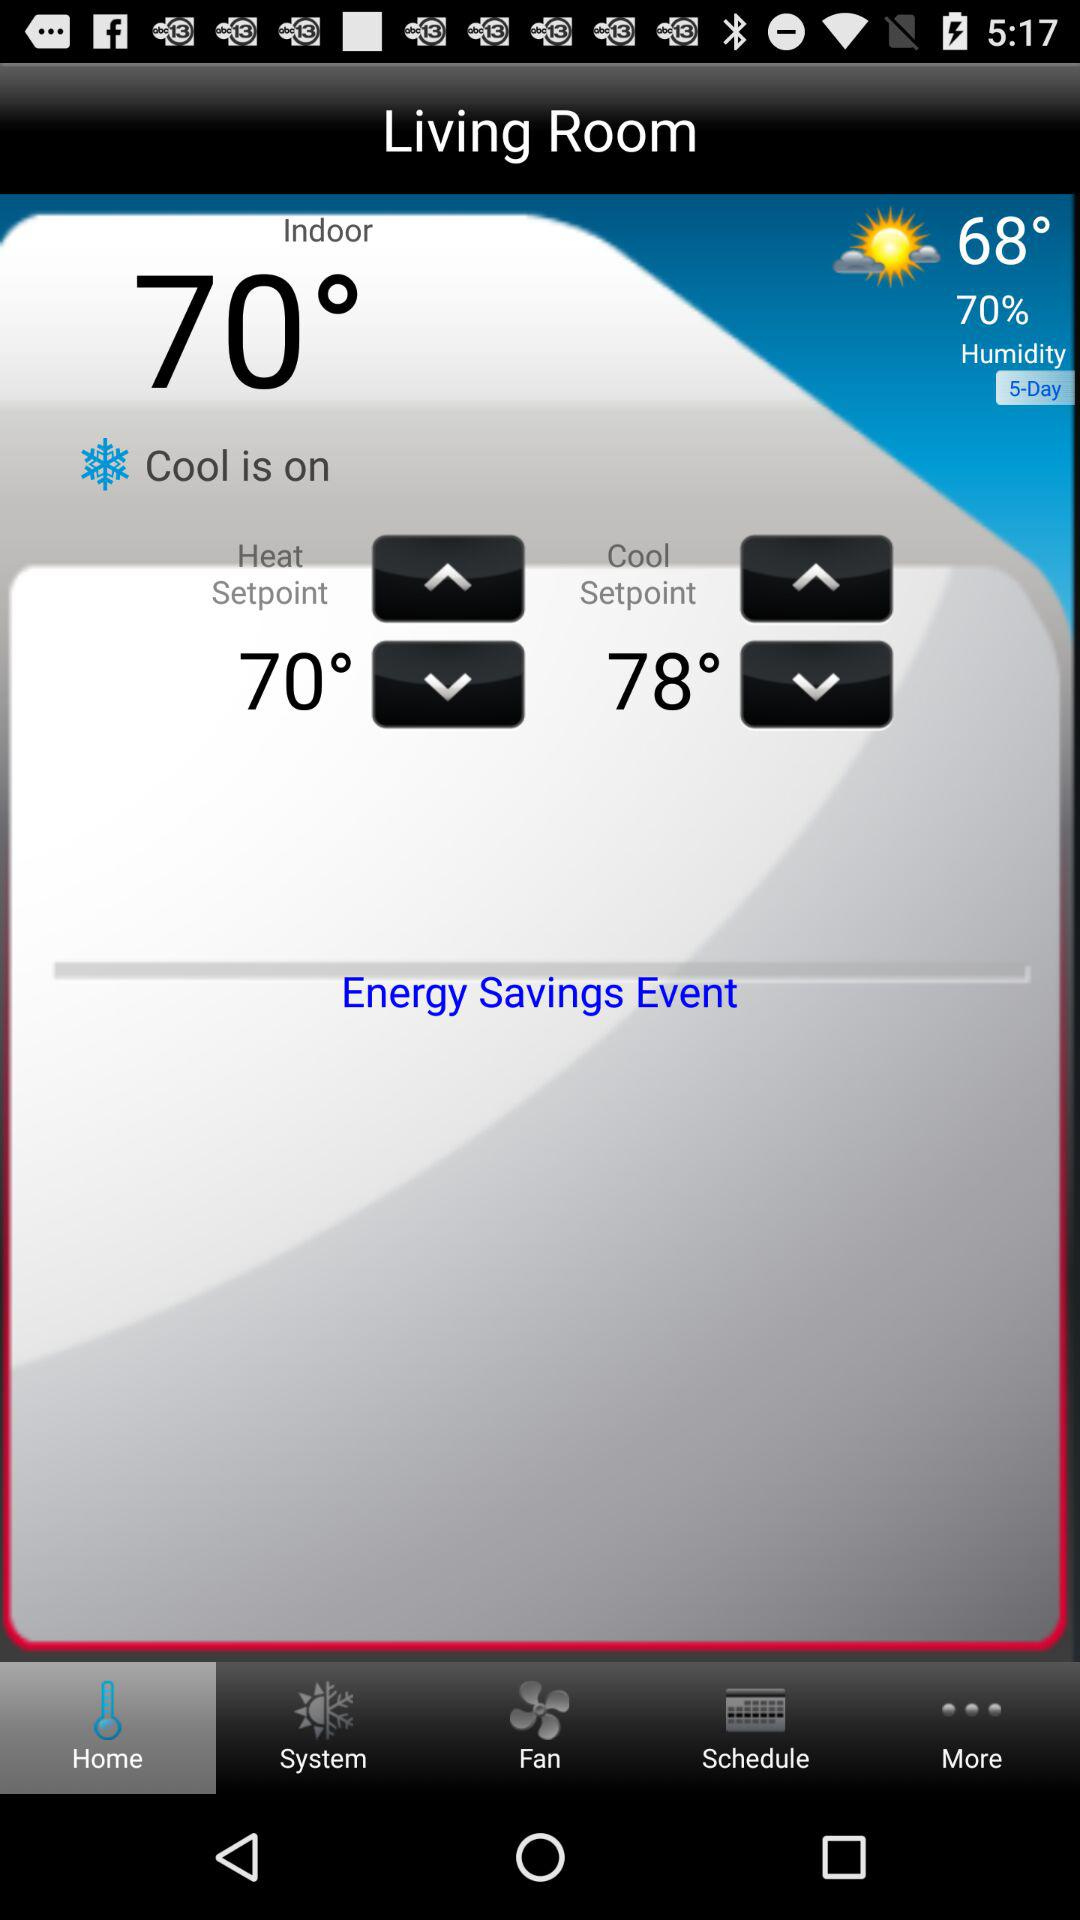Which tab has been selected? The selected tab is "Home". 